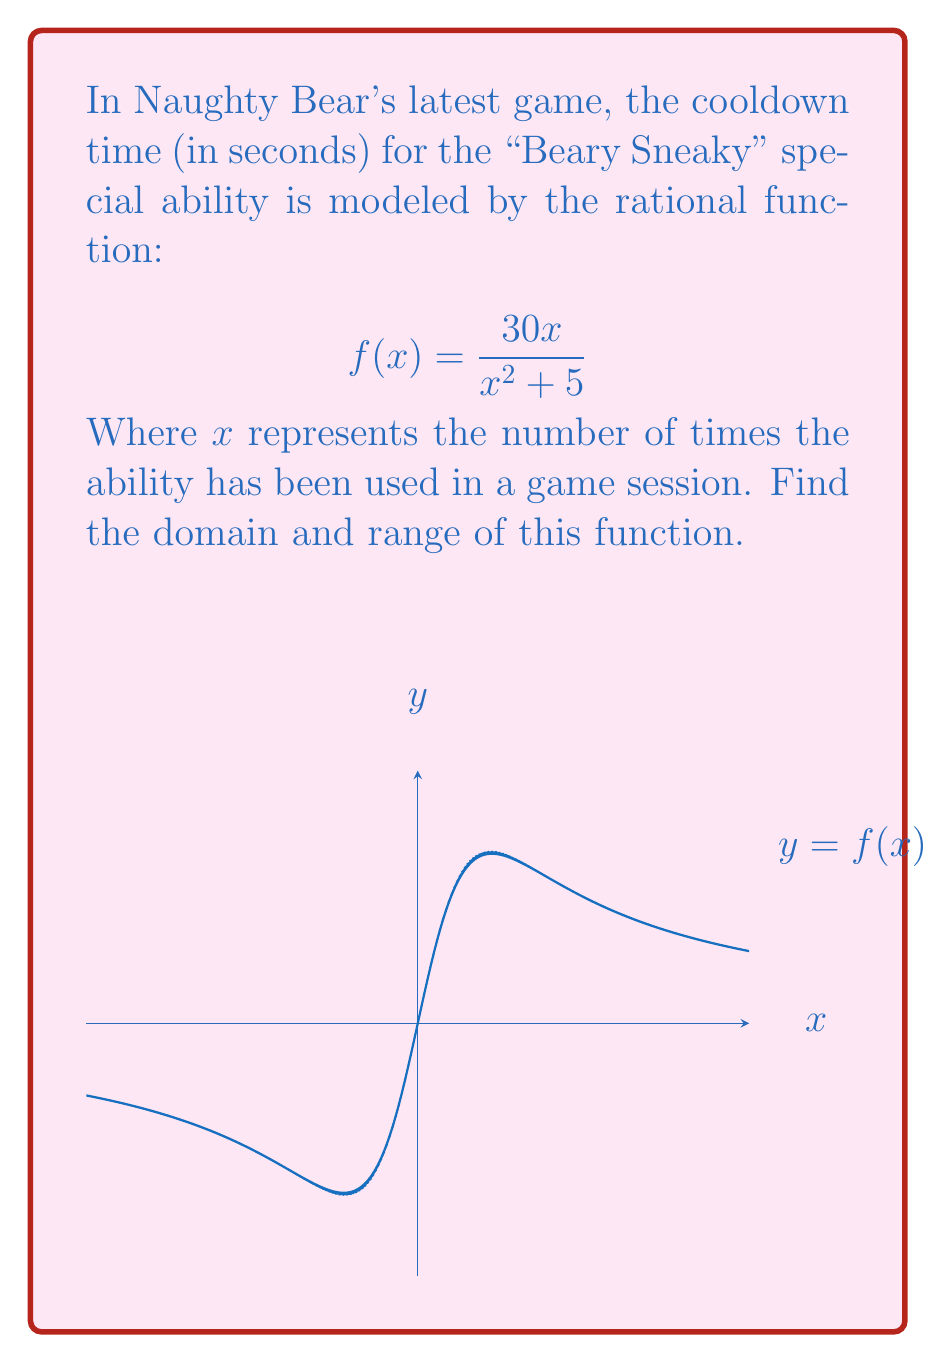Solve this math problem. Let's approach this step-by-step:

1) Domain:
   The domain of a rational function includes all real numbers except those that make the denominator zero.
   
   Set the denominator to zero:
   $$x^2 + 5 = 0$$
   $$x^2 = -5$$
   
   Since there are no real solutions to this equation (as a squared term can't be negative), the denominator is never zero.

   Therefore, the domain is all real numbers: $(-\infty, \infty)$

2) Range:
   To find the range, let's analyze the function:

   a) As $x$ approaches $\pm\infty$, both numerator and denominator approach infinity, but the denominator grows faster. So, $\lim_{x \to \pm\infty} f(x) = 0$.

   b) To find the maximum/minimum, let's differentiate:
      $$f'(x) = \frac{30(x^2+5) - 30x(2x)}{(x^2+5)^2} = \frac{30(5-x^2)}{(x^2+5)^2}$$

   c) Set $f'(x) = 0$:
      $$\frac{30(5-x^2)}{(x^2+5)^2} = 0$$
      $$5-x^2 = 0$$
      $$x = \pm\sqrt{5}$$

   d) The maximum occurs at $x = \sqrt{5}$ and $x = -\sqrt{5}$. Let's calculate the maximum value:
      $$f(\sqrt{5}) = \frac{30\sqrt{5}}{5+5} = \frac{3\sqrt{5}}{2} \approx 3.35$$

Therefore, the range is $(0, \frac{3\sqrt{5}}{2}]$.
Answer: Domain: $(-\infty, \infty)$, Range: $(0, \frac{3\sqrt{5}}{2}]$ 